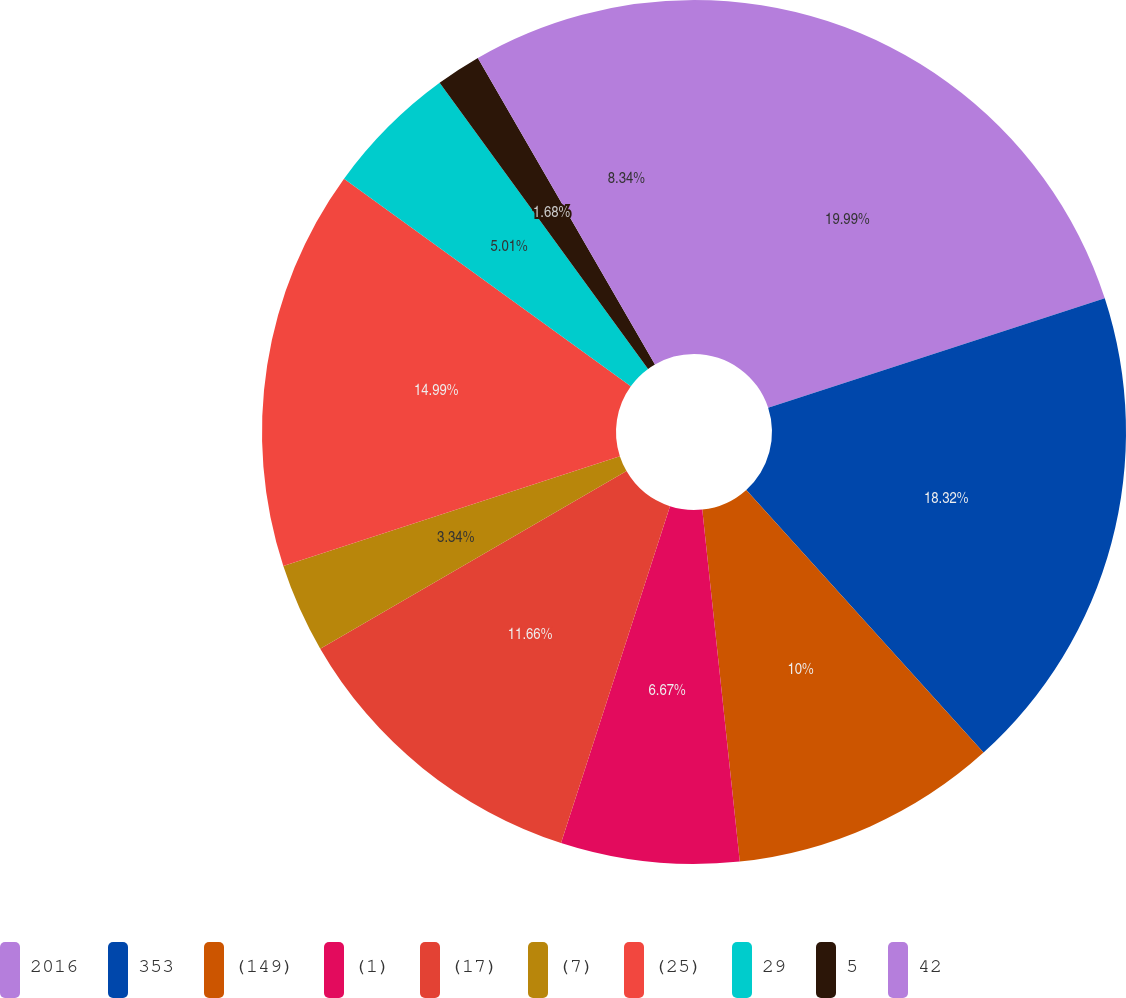<chart> <loc_0><loc_0><loc_500><loc_500><pie_chart><fcel>2016<fcel>353<fcel>(149)<fcel>(1)<fcel>(17)<fcel>(7)<fcel>(25)<fcel>29<fcel>5<fcel>42<nl><fcel>19.99%<fcel>18.32%<fcel>10.0%<fcel>6.67%<fcel>11.66%<fcel>3.34%<fcel>14.99%<fcel>5.01%<fcel>1.68%<fcel>8.34%<nl></chart> 